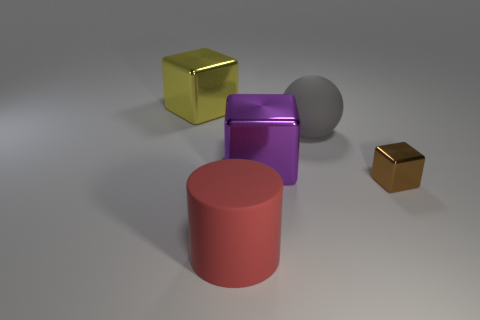Add 1 big yellow shiny things. How many objects exist? 6 Subtract all cubes. How many objects are left? 2 Add 4 big gray cylinders. How many big gray cylinders exist? 4 Subtract 0 brown cylinders. How many objects are left? 5 Subtract all big red matte objects. Subtract all big matte things. How many objects are left? 2 Add 2 tiny blocks. How many tiny blocks are left? 3 